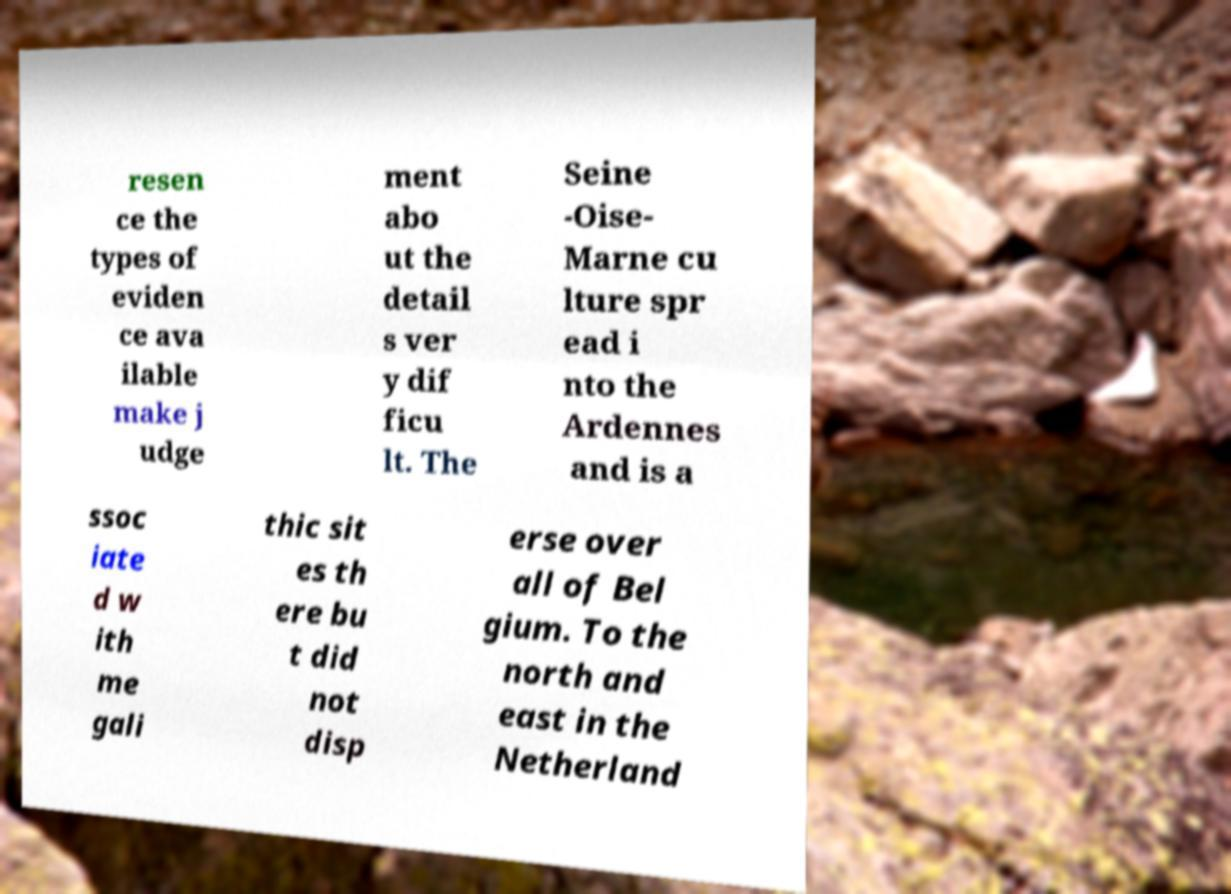Can you read and provide the text displayed in the image?This photo seems to have some interesting text. Can you extract and type it out for me? resen ce the types of eviden ce ava ilable make j udge ment abo ut the detail s ver y dif ficu lt. The Seine -Oise- Marne cu lture spr ead i nto the Ardennes and is a ssoc iate d w ith me gali thic sit es th ere bu t did not disp erse over all of Bel gium. To the north and east in the Netherland 